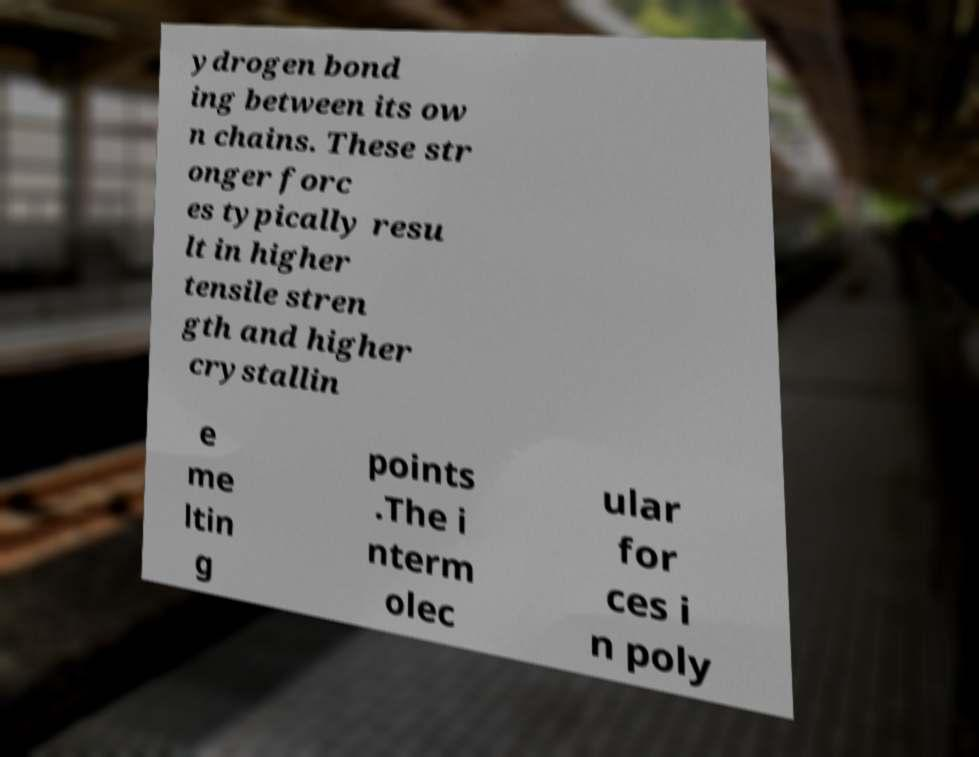What messages or text are displayed in this image? I need them in a readable, typed format. ydrogen bond ing between its ow n chains. These str onger forc es typically resu lt in higher tensile stren gth and higher crystallin e me ltin g points .The i nterm olec ular for ces i n poly 